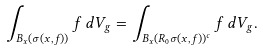<formula> <loc_0><loc_0><loc_500><loc_500>\int _ { B _ { x } ( \sigma ( x , f ) ) } f \, d V _ { g } = \int _ { B _ { x } ( R _ { 0 } \sigma ( x , f ) ) ^ { c } } f \, d V _ { g } .</formula> 